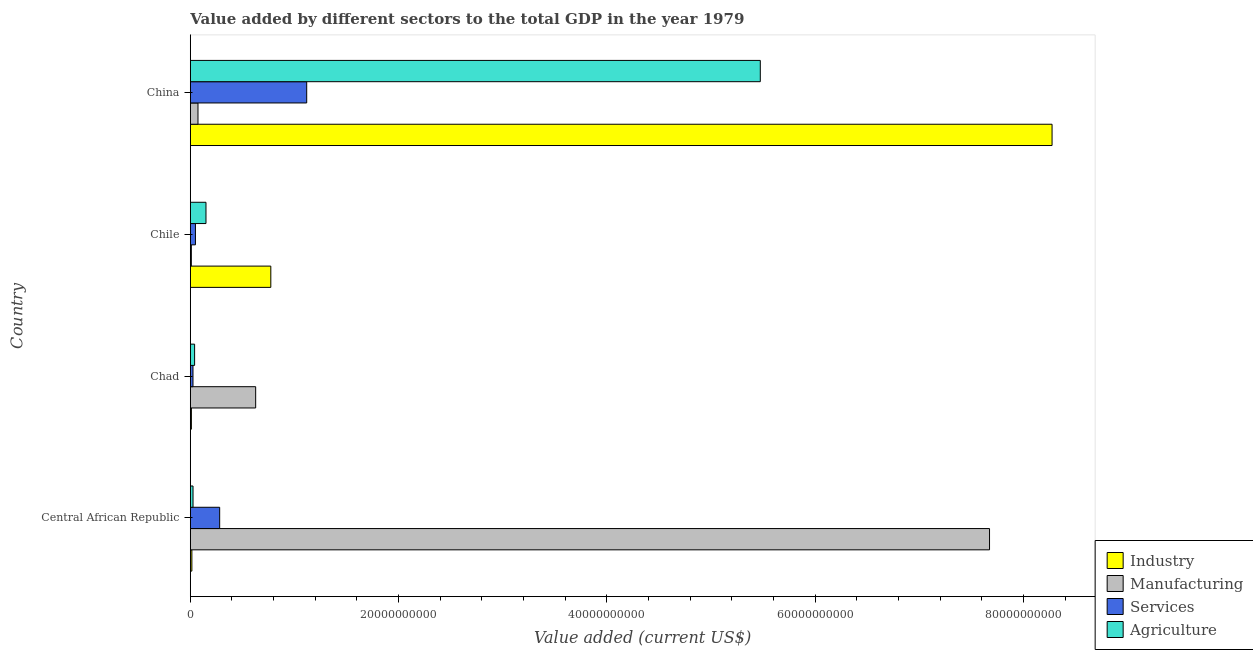How many different coloured bars are there?
Offer a terse response. 4. What is the label of the 3rd group of bars from the top?
Provide a succinct answer. Chad. What is the value added by manufacturing sector in China?
Keep it short and to the point. 7.39e+08. Across all countries, what is the maximum value added by services sector?
Offer a very short reply. 1.12e+1. Across all countries, what is the minimum value added by agricultural sector?
Ensure brevity in your answer.  2.62e+08. In which country was the value added by manufacturing sector minimum?
Offer a very short reply. Chile. What is the total value added by agricultural sector in the graph?
Offer a terse response. 5.69e+1. What is the difference between the value added by industrial sector in Chad and that in China?
Ensure brevity in your answer.  -8.26e+1. What is the difference between the value added by agricultural sector in Central African Republic and the value added by manufacturing sector in Chile?
Provide a short and direct response. 1.61e+08. What is the average value added by agricultural sector per country?
Offer a very short reply. 1.42e+1. What is the difference between the value added by industrial sector and value added by services sector in China?
Your response must be concise. 7.16e+1. In how many countries, is the value added by agricultural sector greater than 4000000000 US$?
Offer a terse response. 1. What is the ratio of the value added by services sector in Chad to that in Chile?
Ensure brevity in your answer.  0.52. What is the difference between the highest and the second highest value added by manufacturing sector?
Give a very brief answer. 7.05e+1. What is the difference between the highest and the lowest value added by manufacturing sector?
Ensure brevity in your answer.  7.66e+1. Is the sum of the value added by industrial sector in Chad and Chile greater than the maximum value added by services sector across all countries?
Ensure brevity in your answer.  No. Is it the case that in every country, the sum of the value added by services sector and value added by agricultural sector is greater than the sum of value added by industrial sector and value added by manufacturing sector?
Provide a short and direct response. No. What does the 1st bar from the top in Chad represents?
Give a very brief answer. Agriculture. What does the 3rd bar from the bottom in Central African Republic represents?
Provide a short and direct response. Services. How many bars are there?
Make the answer very short. 16. How many countries are there in the graph?
Ensure brevity in your answer.  4. Does the graph contain grids?
Your answer should be compact. No. How many legend labels are there?
Provide a short and direct response. 4. What is the title of the graph?
Your answer should be compact. Value added by different sectors to the total GDP in the year 1979. Does "Belgium" appear as one of the legend labels in the graph?
Keep it short and to the point. No. What is the label or title of the X-axis?
Keep it short and to the point. Value added (current US$). What is the label or title of the Y-axis?
Provide a short and direct response. Country. What is the Value added (current US$) of Industry in Central African Republic?
Your answer should be compact. 1.51e+08. What is the Value added (current US$) in Manufacturing in Central African Republic?
Make the answer very short. 7.67e+1. What is the Value added (current US$) in Services in Central African Republic?
Make the answer very short. 2.82e+09. What is the Value added (current US$) in Agriculture in Central African Republic?
Offer a terse response. 2.62e+08. What is the Value added (current US$) in Industry in Chad?
Your response must be concise. 1.06e+08. What is the Value added (current US$) in Manufacturing in Chad?
Provide a short and direct response. 6.28e+09. What is the Value added (current US$) of Services in Chad?
Your answer should be very brief. 2.58e+08. What is the Value added (current US$) in Agriculture in Chad?
Provide a short and direct response. 4.14e+08. What is the Value added (current US$) in Industry in Chile?
Your answer should be very brief. 7.73e+09. What is the Value added (current US$) of Manufacturing in Chile?
Offer a very short reply. 1.01e+08. What is the Value added (current US$) in Services in Chile?
Provide a short and direct response. 4.95e+08. What is the Value added (current US$) of Agriculture in Chile?
Keep it short and to the point. 1.51e+09. What is the Value added (current US$) in Industry in China?
Your answer should be compact. 8.28e+1. What is the Value added (current US$) in Manufacturing in China?
Make the answer very short. 7.39e+08. What is the Value added (current US$) in Services in China?
Your answer should be compact. 1.12e+1. What is the Value added (current US$) in Agriculture in China?
Give a very brief answer. 5.47e+1. Across all countries, what is the maximum Value added (current US$) in Industry?
Offer a terse response. 8.28e+1. Across all countries, what is the maximum Value added (current US$) of Manufacturing?
Ensure brevity in your answer.  7.67e+1. Across all countries, what is the maximum Value added (current US$) of Services?
Your answer should be very brief. 1.12e+1. Across all countries, what is the maximum Value added (current US$) of Agriculture?
Make the answer very short. 5.47e+1. Across all countries, what is the minimum Value added (current US$) in Industry?
Ensure brevity in your answer.  1.06e+08. Across all countries, what is the minimum Value added (current US$) of Manufacturing?
Offer a terse response. 1.01e+08. Across all countries, what is the minimum Value added (current US$) in Services?
Offer a very short reply. 2.58e+08. Across all countries, what is the minimum Value added (current US$) in Agriculture?
Provide a short and direct response. 2.62e+08. What is the total Value added (current US$) of Industry in the graph?
Ensure brevity in your answer.  9.07e+1. What is the total Value added (current US$) of Manufacturing in the graph?
Ensure brevity in your answer.  8.39e+1. What is the total Value added (current US$) of Services in the graph?
Provide a succinct answer. 1.48e+1. What is the total Value added (current US$) of Agriculture in the graph?
Your answer should be very brief. 5.69e+1. What is the difference between the Value added (current US$) in Industry in Central African Republic and that in Chad?
Provide a short and direct response. 4.58e+07. What is the difference between the Value added (current US$) in Manufacturing in Central African Republic and that in Chad?
Ensure brevity in your answer.  7.05e+1. What is the difference between the Value added (current US$) of Services in Central African Republic and that in Chad?
Keep it short and to the point. 2.56e+09. What is the difference between the Value added (current US$) in Agriculture in Central African Republic and that in Chad?
Your answer should be compact. -1.52e+08. What is the difference between the Value added (current US$) of Industry in Central African Republic and that in Chile?
Offer a very short reply. -7.58e+09. What is the difference between the Value added (current US$) in Manufacturing in Central African Republic and that in Chile?
Your answer should be very brief. 7.66e+1. What is the difference between the Value added (current US$) in Services in Central African Republic and that in Chile?
Your response must be concise. 2.33e+09. What is the difference between the Value added (current US$) in Agriculture in Central African Republic and that in Chile?
Ensure brevity in your answer.  -1.24e+09. What is the difference between the Value added (current US$) of Industry in Central African Republic and that in China?
Your answer should be very brief. -8.26e+1. What is the difference between the Value added (current US$) of Manufacturing in Central African Republic and that in China?
Your answer should be compact. 7.60e+1. What is the difference between the Value added (current US$) in Services in Central African Republic and that in China?
Keep it short and to the point. -8.36e+09. What is the difference between the Value added (current US$) of Agriculture in Central African Republic and that in China?
Your answer should be very brief. -5.45e+1. What is the difference between the Value added (current US$) of Industry in Chad and that in Chile?
Give a very brief answer. -7.63e+09. What is the difference between the Value added (current US$) of Manufacturing in Chad and that in Chile?
Ensure brevity in your answer.  6.18e+09. What is the difference between the Value added (current US$) of Services in Chad and that in Chile?
Provide a succinct answer. -2.38e+08. What is the difference between the Value added (current US$) in Agriculture in Chad and that in Chile?
Your answer should be very brief. -1.09e+09. What is the difference between the Value added (current US$) of Industry in Chad and that in China?
Offer a terse response. -8.26e+1. What is the difference between the Value added (current US$) in Manufacturing in Chad and that in China?
Ensure brevity in your answer.  5.54e+09. What is the difference between the Value added (current US$) of Services in Chad and that in China?
Give a very brief answer. -1.09e+1. What is the difference between the Value added (current US$) of Agriculture in Chad and that in China?
Your answer should be very brief. -5.43e+1. What is the difference between the Value added (current US$) in Industry in Chile and that in China?
Offer a terse response. -7.50e+1. What is the difference between the Value added (current US$) of Manufacturing in Chile and that in China?
Offer a very short reply. -6.38e+08. What is the difference between the Value added (current US$) in Services in Chile and that in China?
Your answer should be compact. -1.07e+1. What is the difference between the Value added (current US$) of Agriculture in Chile and that in China?
Make the answer very short. -5.32e+1. What is the difference between the Value added (current US$) of Industry in Central African Republic and the Value added (current US$) of Manufacturing in Chad?
Your answer should be compact. -6.13e+09. What is the difference between the Value added (current US$) in Industry in Central African Republic and the Value added (current US$) in Services in Chad?
Provide a succinct answer. -1.06e+08. What is the difference between the Value added (current US$) in Industry in Central African Republic and the Value added (current US$) in Agriculture in Chad?
Your response must be concise. -2.63e+08. What is the difference between the Value added (current US$) of Manufacturing in Central African Republic and the Value added (current US$) of Services in Chad?
Provide a succinct answer. 7.65e+1. What is the difference between the Value added (current US$) of Manufacturing in Central African Republic and the Value added (current US$) of Agriculture in Chad?
Keep it short and to the point. 7.63e+1. What is the difference between the Value added (current US$) of Services in Central African Republic and the Value added (current US$) of Agriculture in Chad?
Offer a terse response. 2.41e+09. What is the difference between the Value added (current US$) in Industry in Central African Republic and the Value added (current US$) in Manufacturing in Chile?
Make the answer very short. 5.03e+07. What is the difference between the Value added (current US$) of Industry in Central African Republic and the Value added (current US$) of Services in Chile?
Your answer should be compact. -3.44e+08. What is the difference between the Value added (current US$) of Industry in Central African Republic and the Value added (current US$) of Agriculture in Chile?
Your response must be concise. -1.36e+09. What is the difference between the Value added (current US$) of Manufacturing in Central African Republic and the Value added (current US$) of Services in Chile?
Keep it short and to the point. 7.63e+1. What is the difference between the Value added (current US$) of Manufacturing in Central African Republic and the Value added (current US$) of Agriculture in Chile?
Make the answer very short. 7.52e+1. What is the difference between the Value added (current US$) in Services in Central African Republic and the Value added (current US$) in Agriculture in Chile?
Offer a very short reply. 1.31e+09. What is the difference between the Value added (current US$) of Industry in Central African Republic and the Value added (current US$) of Manufacturing in China?
Ensure brevity in your answer.  -5.87e+08. What is the difference between the Value added (current US$) of Industry in Central African Republic and the Value added (current US$) of Services in China?
Ensure brevity in your answer.  -1.10e+1. What is the difference between the Value added (current US$) of Industry in Central African Republic and the Value added (current US$) of Agriculture in China?
Keep it short and to the point. -5.46e+1. What is the difference between the Value added (current US$) of Manufacturing in Central African Republic and the Value added (current US$) of Services in China?
Keep it short and to the point. 6.56e+1. What is the difference between the Value added (current US$) of Manufacturing in Central African Republic and the Value added (current US$) of Agriculture in China?
Give a very brief answer. 2.20e+1. What is the difference between the Value added (current US$) of Services in Central African Republic and the Value added (current US$) of Agriculture in China?
Your answer should be very brief. -5.19e+1. What is the difference between the Value added (current US$) of Industry in Chad and the Value added (current US$) of Manufacturing in Chile?
Your answer should be very brief. 4.53e+06. What is the difference between the Value added (current US$) in Industry in Chad and the Value added (current US$) in Services in Chile?
Offer a terse response. -3.90e+08. What is the difference between the Value added (current US$) of Industry in Chad and the Value added (current US$) of Agriculture in Chile?
Your answer should be very brief. -1.40e+09. What is the difference between the Value added (current US$) of Manufacturing in Chad and the Value added (current US$) of Services in Chile?
Make the answer very short. 5.78e+09. What is the difference between the Value added (current US$) of Manufacturing in Chad and the Value added (current US$) of Agriculture in Chile?
Offer a terse response. 4.77e+09. What is the difference between the Value added (current US$) of Services in Chad and the Value added (current US$) of Agriculture in Chile?
Keep it short and to the point. -1.25e+09. What is the difference between the Value added (current US$) in Industry in Chad and the Value added (current US$) in Manufacturing in China?
Provide a succinct answer. -6.33e+08. What is the difference between the Value added (current US$) of Industry in Chad and the Value added (current US$) of Services in China?
Your answer should be compact. -1.11e+1. What is the difference between the Value added (current US$) of Industry in Chad and the Value added (current US$) of Agriculture in China?
Your answer should be very brief. -5.46e+1. What is the difference between the Value added (current US$) of Manufacturing in Chad and the Value added (current US$) of Services in China?
Provide a succinct answer. -4.90e+09. What is the difference between the Value added (current US$) in Manufacturing in Chad and the Value added (current US$) in Agriculture in China?
Offer a very short reply. -4.85e+1. What is the difference between the Value added (current US$) in Services in Chad and the Value added (current US$) in Agriculture in China?
Provide a succinct answer. -5.45e+1. What is the difference between the Value added (current US$) in Industry in Chile and the Value added (current US$) in Manufacturing in China?
Offer a very short reply. 6.99e+09. What is the difference between the Value added (current US$) of Industry in Chile and the Value added (current US$) of Services in China?
Ensure brevity in your answer.  -3.45e+09. What is the difference between the Value added (current US$) in Industry in Chile and the Value added (current US$) in Agriculture in China?
Make the answer very short. -4.70e+1. What is the difference between the Value added (current US$) in Manufacturing in Chile and the Value added (current US$) in Services in China?
Provide a succinct answer. -1.11e+1. What is the difference between the Value added (current US$) of Manufacturing in Chile and the Value added (current US$) of Agriculture in China?
Your answer should be compact. -5.46e+1. What is the difference between the Value added (current US$) in Services in Chile and the Value added (current US$) in Agriculture in China?
Provide a short and direct response. -5.42e+1. What is the average Value added (current US$) of Industry per country?
Keep it short and to the point. 2.27e+1. What is the average Value added (current US$) of Manufacturing per country?
Offer a terse response. 2.10e+1. What is the average Value added (current US$) in Services per country?
Ensure brevity in your answer.  3.69e+09. What is the average Value added (current US$) in Agriculture per country?
Offer a terse response. 1.42e+1. What is the difference between the Value added (current US$) of Industry and Value added (current US$) of Manufacturing in Central African Republic?
Keep it short and to the point. -7.66e+1. What is the difference between the Value added (current US$) of Industry and Value added (current US$) of Services in Central African Republic?
Your answer should be very brief. -2.67e+09. What is the difference between the Value added (current US$) in Industry and Value added (current US$) in Agriculture in Central African Republic?
Keep it short and to the point. -1.11e+08. What is the difference between the Value added (current US$) in Manufacturing and Value added (current US$) in Services in Central African Republic?
Your answer should be very brief. 7.39e+1. What is the difference between the Value added (current US$) of Manufacturing and Value added (current US$) of Agriculture in Central African Republic?
Make the answer very short. 7.65e+1. What is the difference between the Value added (current US$) in Services and Value added (current US$) in Agriculture in Central African Republic?
Offer a very short reply. 2.56e+09. What is the difference between the Value added (current US$) in Industry and Value added (current US$) in Manufacturing in Chad?
Your answer should be very brief. -6.17e+09. What is the difference between the Value added (current US$) of Industry and Value added (current US$) of Services in Chad?
Keep it short and to the point. -1.52e+08. What is the difference between the Value added (current US$) in Industry and Value added (current US$) in Agriculture in Chad?
Keep it short and to the point. -3.09e+08. What is the difference between the Value added (current US$) of Manufacturing and Value added (current US$) of Services in Chad?
Provide a succinct answer. 6.02e+09. What is the difference between the Value added (current US$) in Manufacturing and Value added (current US$) in Agriculture in Chad?
Ensure brevity in your answer.  5.86e+09. What is the difference between the Value added (current US$) in Services and Value added (current US$) in Agriculture in Chad?
Your answer should be very brief. -1.57e+08. What is the difference between the Value added (current US$) of Industry and Value added (current US$) of Manufacturing in Chile?
Your response must be concise. 7.63e+09. What is the difference between the Value added (current US$) of Industry and Value added (current US$) of Services in Chile?
Provide a short and direct response. 7.24e+09. What is the difference between the Value added (current US$) of Industry and Value added (current US$) of Agriculture in Chile?
Keep it short and to the point. 6.22e+09. What is the difference between the Value added (current US$) of Manufacturing and Value added (current US$) of Services in Chile?
Offer a terse response. -3.94e+08. What is the difference between the Value added (current US$) of Manufacturing and Value added (current US$) of Agriculture in Chile?
Give a very brief answer. -1.41e+09. What is the difference between the Value added (current US$) of Services and Value added (current US$) of Agriculture in Chile?
Provide a short and direct response. -1.01e+09. What is the difference between the Value added (current US$) of Industry and Value added (current US$) of Manufacturing in China?
Offer a terse response. 8.20e+1. What is the difference between the Value added (current US$) of Industry and Value added (current US$) of Services in China?
Your answer should be compact. 7.16e+1. What is the difference between the Value added (current US$) of Industry and Value added (current US$) of Agriculture in China?
Give a very brief answer. 2.80e+1. What is the difference between the Value added (current US$) in Manufacturing and Value added (current US$) in Services in China?
Your response must be concise. -1.04e+1. What is the difference between the Value added (current US$) in Manufacturing and Value added (current US$) in Agriculture in China?
Give a very brief answer. -5.40e+1. What is the difference between the Value added (current US$) in Services and Value added (current US$) in Agriculture in China?
Provide a short and direct response. -4.36e+1. What is the ratio of the Value added (current US$) in Industry in Central African Republic to that in Chad?
Provide a succinct answer. 1.43. What is the ratio of the Value added (current US$) in Manufacturing in Central African Republic to that in Chad?
Make the answer very short. 12.23. What is the ratio of the Value added (current US$) of Services in Central African Republic to that in Chad?
Make the answer very short. 10.95. What is the ratio of the Value added (current US$) of Agriculture in Central African Republic to that in Chad?
Provide a short and direct response. 0.63. What is the ratio of the Value added (current US$) in Industry in Central African Republic to that in Chile?
Offer a very short reply. 0.02. What is the ratio of the Value added (current US$) of Manufacturing in Central African Republic to that in Chile?
Your response must be concise. 759.35. What is the ratio of the Value added (current US$) in Services in Central African Republic to that in Chile?
Ensure brevity in your answer.  5.69. What is the ratio of the Value added (current US$) in Agriculture in Central African Republic to that in Chile?
Offer a very short reply. 0.17. What is the ratio of the Value added (current US$) in Industry in Central African Republic to that in China?
Ensure brevity in your answer.  0. What is the ratio of the Value added (current US$) of Manufacturing in Central African Republic to that in China?
Make the answer very short. 103.88. What is the ratio of the Value added (current US$) of Services in Central African Republic to that in China?
Keep it short and to the point. 0.25. What is the ratio of the Value added (current US$) in Agriculture in Central African Republic to that in China?
Your answer should be very brief. 0. What is the ratio of the Value added (current US$) in Industry in Chad to that in Chile?
Give a very brief answer. 0.01. What is the ratio of the Value added (current US$) in Manufacturing in Chad to that in Chile?
Keep it short and to the point. 62.11. What is the ratio of the Value added (current US$) of Services in Chad to that in Chile?
Give a very brief answer. 0.52. What is the ratio of the Value added (current US$) in Agriculture in Chad to that in Chile?
Your answer should be very brief. 0.28. What is the ratio of the Value added (current US$) in Industry in Chad to that in China?
Your response must be concise. 0. What is the ratio of the Value added (current US$) in Manufacturing in Chad to that in China?
Provide a succinct answer. 8.5. What is the ratio of the Value added (current US$) of Services in Chad to that in China?
Provide a short and direct response. 0.02. What is the ratio of the Value added (current US$) in Agriculture in Chad to that in China?
Your response must be concise. 0.01. What is the ratio of the Value added (current US$) of Industry in Chile to that in China?
Offer a terse response. 0.09. What is the ratio of the Value added (current US$) of Manufacturing in Chile to that in China?
Your response must be concise. 0.14. What is the ratio of the Value added (current US$) of Services in Chile to that in China?
Provide a succinct answer. 0.04. What is the ratio of the Value added (current US$) in Agriculture in Chile to that in China?
Make the answer very short. 0.03. What is the difference between the highest and the second highest Value added (current US$) of Industry?
Offer a terse response. 7.50e+1. What is the difference between the highest and the second highest Value added (current US$) in Manufacturing?
Offer a very short reply. 7.05e+1. What is the difference between the highest and the second highest Value added (current US$) of Services?
Ensure brevity in your answer.  8.36e+09. What is the difference between the highest and the second highest Value added (current US$) in Agriculture?
Keep it short and to the point. 5.32e+1. What is the difference between the highest and the lowest Value added (current US$) of Industry?
Offer a terse response. 8.26e+1. What is the difference between the highest and the lowest Value added (current US$) in Manufacturing?
Provide a short and direct response. 7.66e+1. What is the difference between the highest and the lowest Value added (current US$) in Services?
Offer a very short reply. 1.09e+1. What is the difference between the highest and the lowest Value added (current US$) in Agriculture?
Your response must be concise. 5.45e+1. 